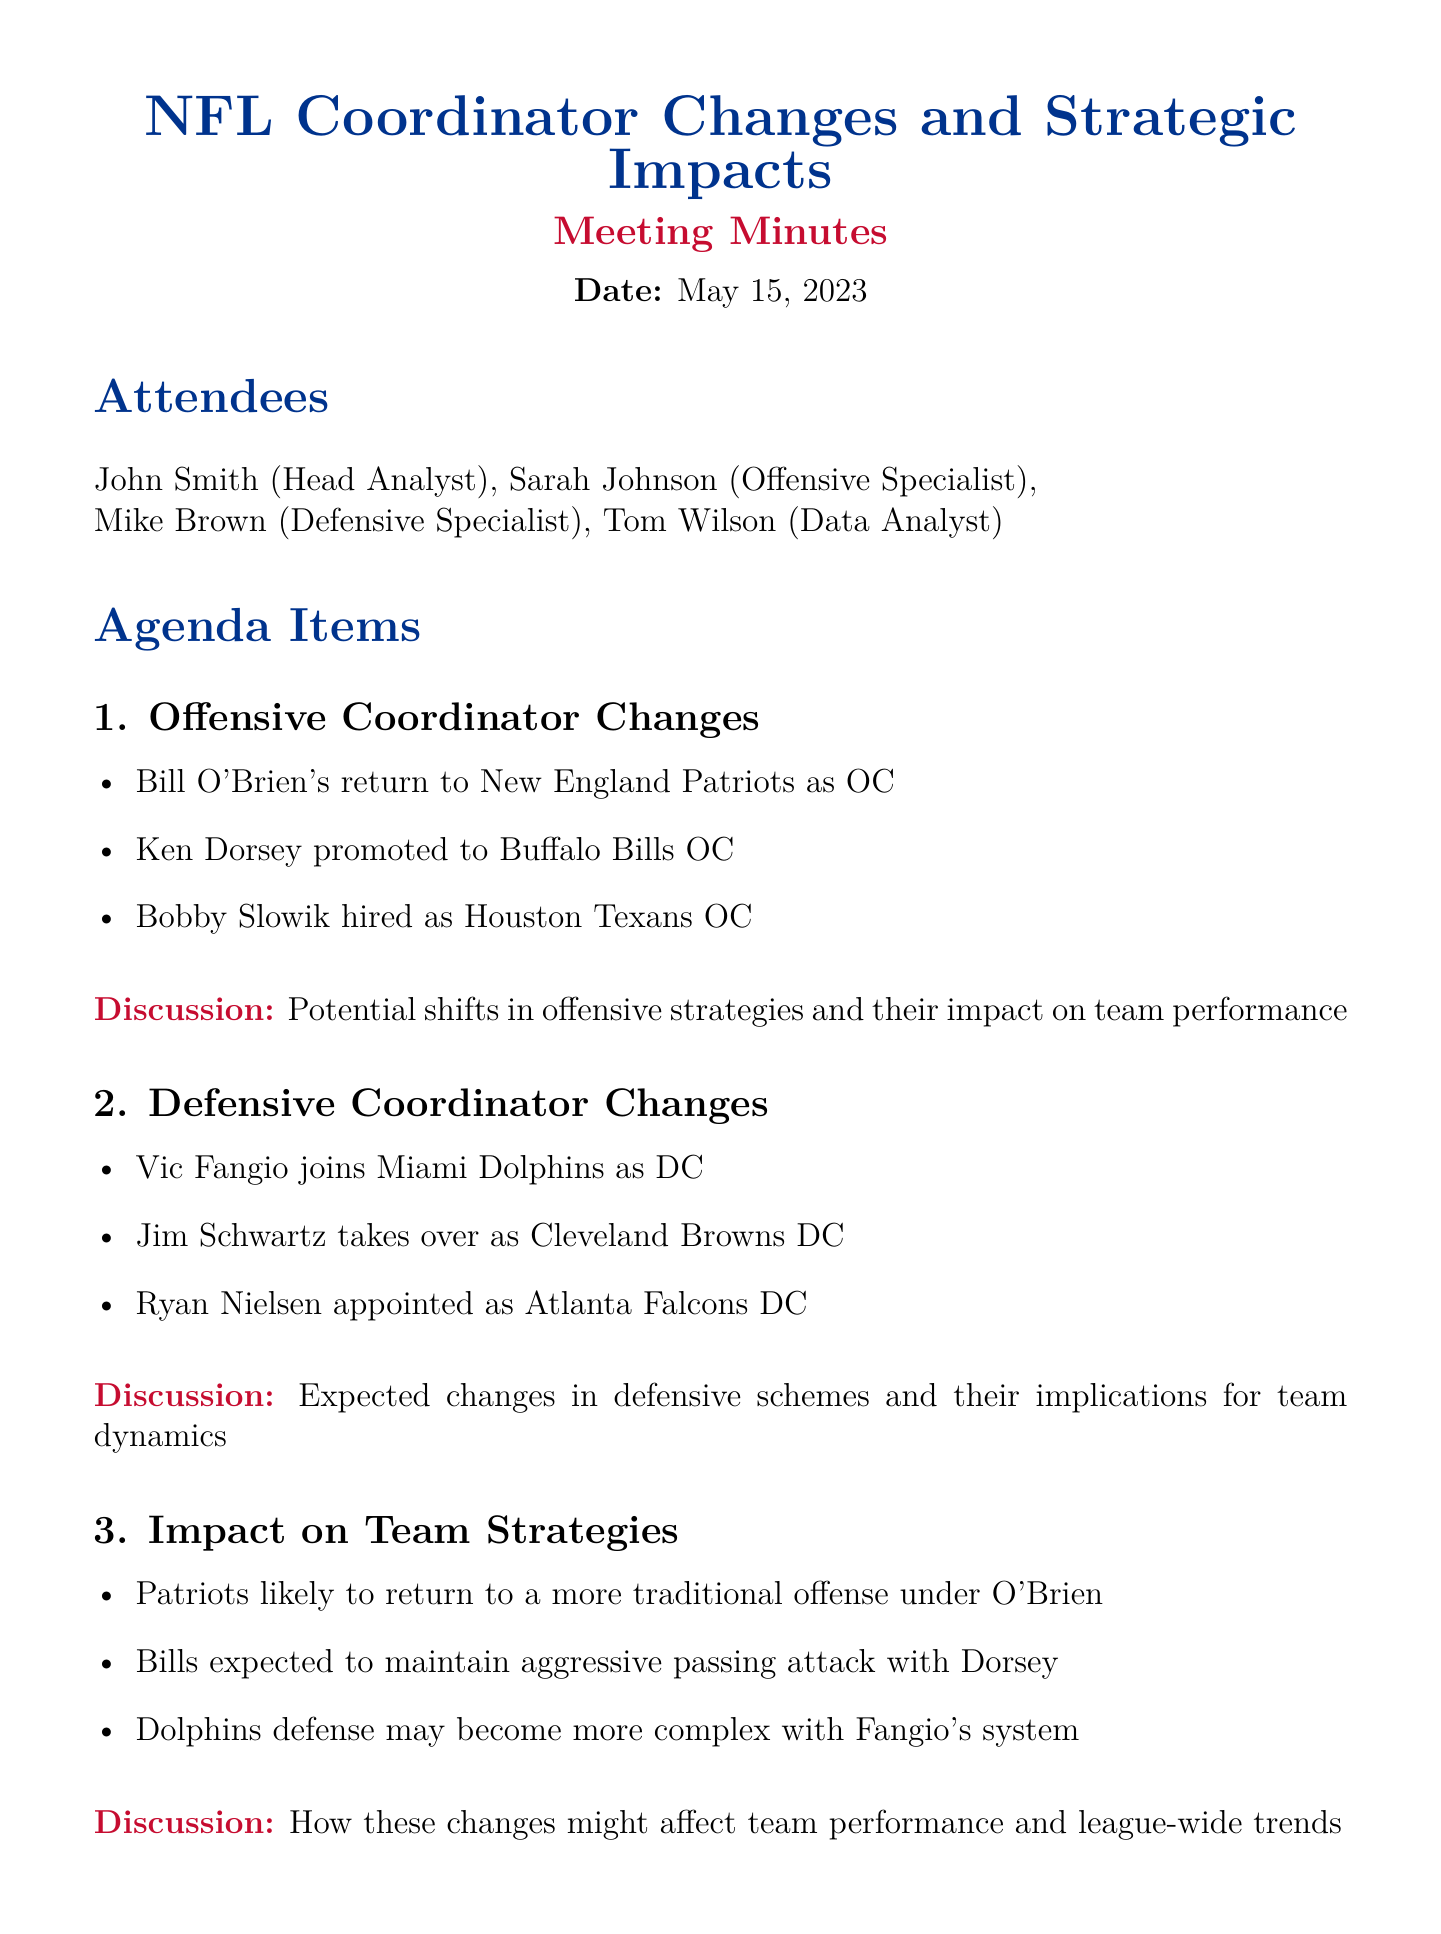What is the meeting title? The meeting title is found at the beginning of the document, indicating the main topic discussed.
Answer: NFL Coordinator Changes and Strategic Impacts Who is the Offensive Specialist? The document includes a list of attendees, one of whom is identified as the Offensive Specialist.
Answer: Sarah Johnson What team did Vic Fangio join as Defensive Coordinator? The key points under Defensive Coordinator Changes mention which team Fangio joined as DC.
Answer: Miami Dolphins What is one expected change for the Buffalo Bills under Ken Dorsey? The discussion section mentions what strategy the Bills are expected to maintain with Dorsey.
Answer: Aggressive passing attack Which action item involves analyzing trends? The action items include tasks that specifically state analyzing play-calling trends.
Answer: Analyze preseason play-calling trends What type of analysis was discussed related to coordinator changes? The Statistical Analysis section outlines the type of insights discussed in relation to coordinator changes.
Answer: Data-driven insights How many attendees were present at the meeting? The list of attendees is provided in the meeting minutes.
Answer: Four 